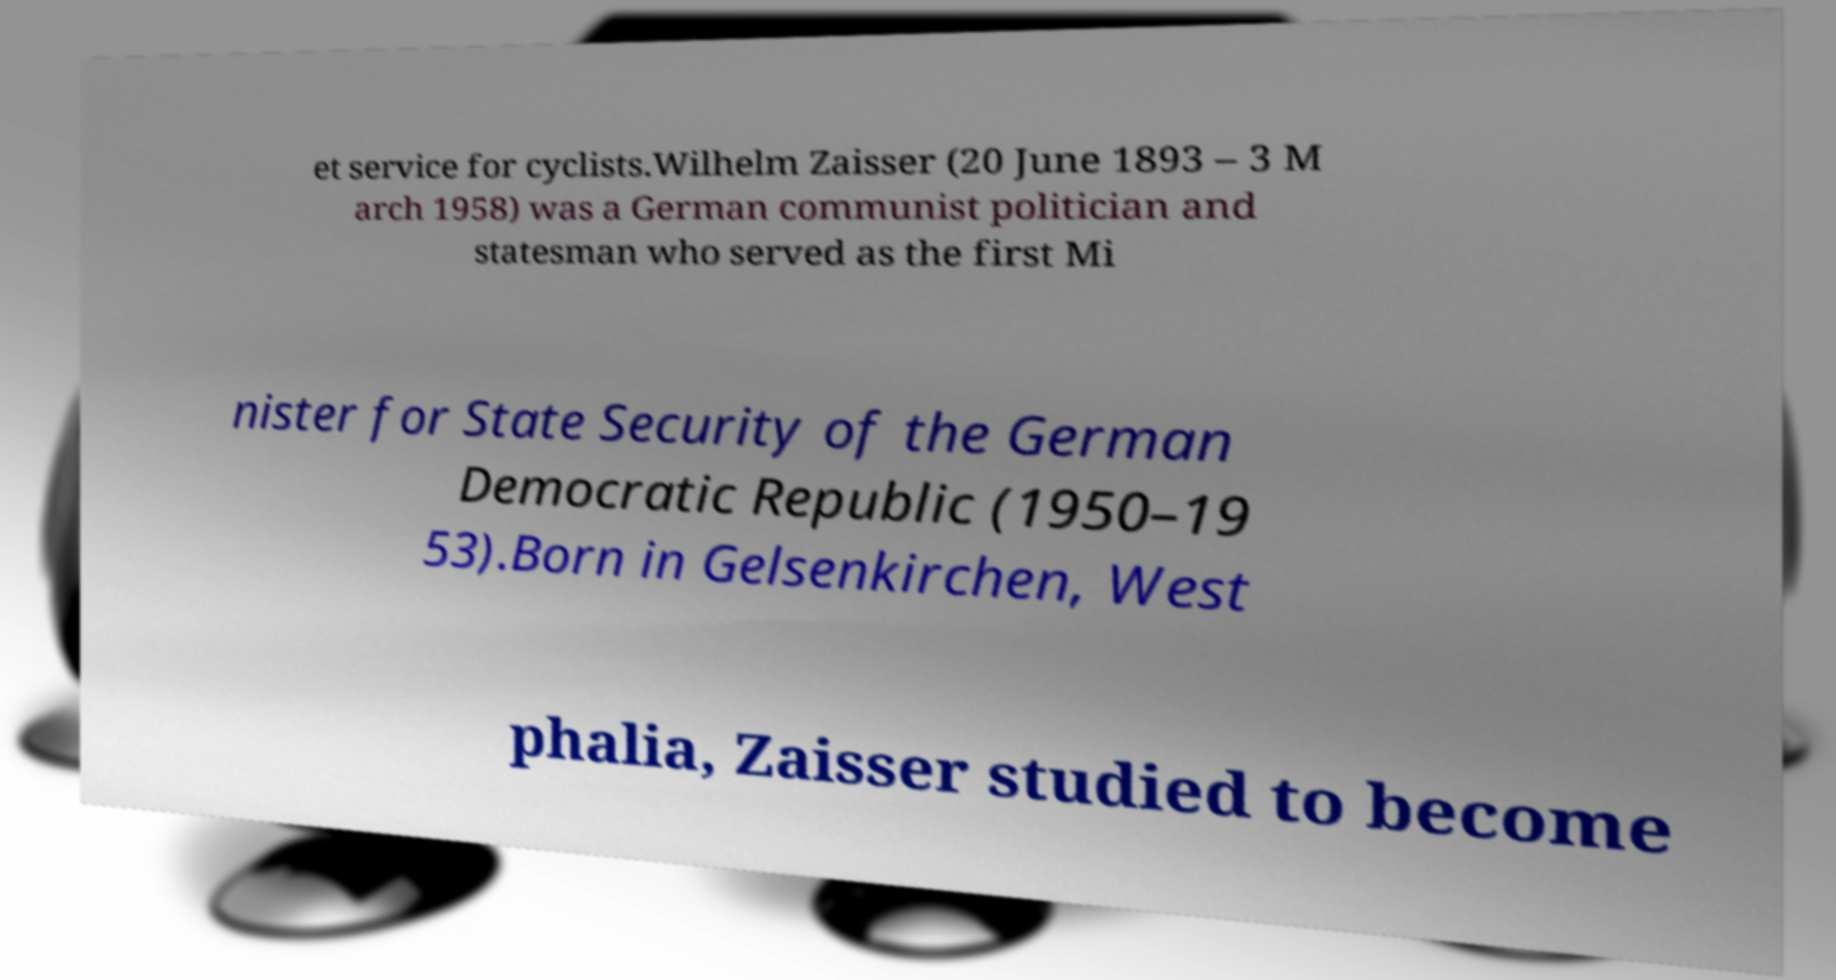I need the written content from this picture converted into text. Can you do that? et service for cyclists.Wilhelm Zaisser (20 June 1893 – 3 M arch 1958) was a German communist politician and statesman who served as the first Mi nister for State Security of the German Democratic Republic (1950–19 53).Born in Gelsenkirchen, West phalia, Zaisser studied to become 